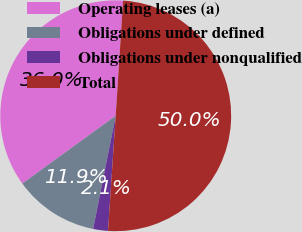Convert chart. <chart><loc_0><loc_0><loc_500><loc_500><pie_chart><fcel>Operating leases (a)<fcel>Obligations under defined<fcel>Obligations under nonqualified<fcel>Total<nl><fcel>36.01%<fcel>11.87%<fcel>2.07%<fcel>50.05%<nl></chart> 